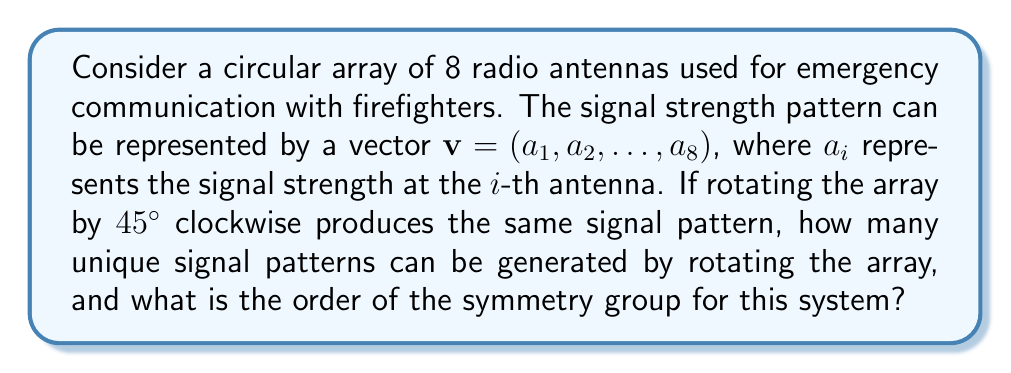What is the answer to this math problem? Let's approach this step-by-step:

1) The symmetry of the system can be analyzed using group theory, specifically cyclic groups.

2) A rotation of 45° clockwise corresponds to shifting the vector one position to the right: 
   $(a_1, a_2, ..., a_8) \rightarrow (a_8, a_1, ..., a_7)$

3) Given that this rotation produces the same pattern, we can conclude:
   $a_1 = a_8, a_2 = a_1, a_3 = a_2, ..., a_8 = a_7$

4) This means that all elements in the vector are equal: $a_1 = a_2 = ... = a_8$

5) The group of rotations that preserve this pattern is isomorphic to the cyclic group $C_8$, as there are 8 possible rotations (including the identity rotation).

6) However, since all rotations produce the same pattern, there is only 1 unique signal pattern.

7) The order of the symmetry group is still 8, as there are 8 symmetry operations (rotations) that preserve the pattern, even though they all result in the same visual pattern.

Therefore, there is 1 unique signal pattern, and the order of the symmetry group is 8.
Answer: 1 unique signal pattern; symmetry group order: 8 